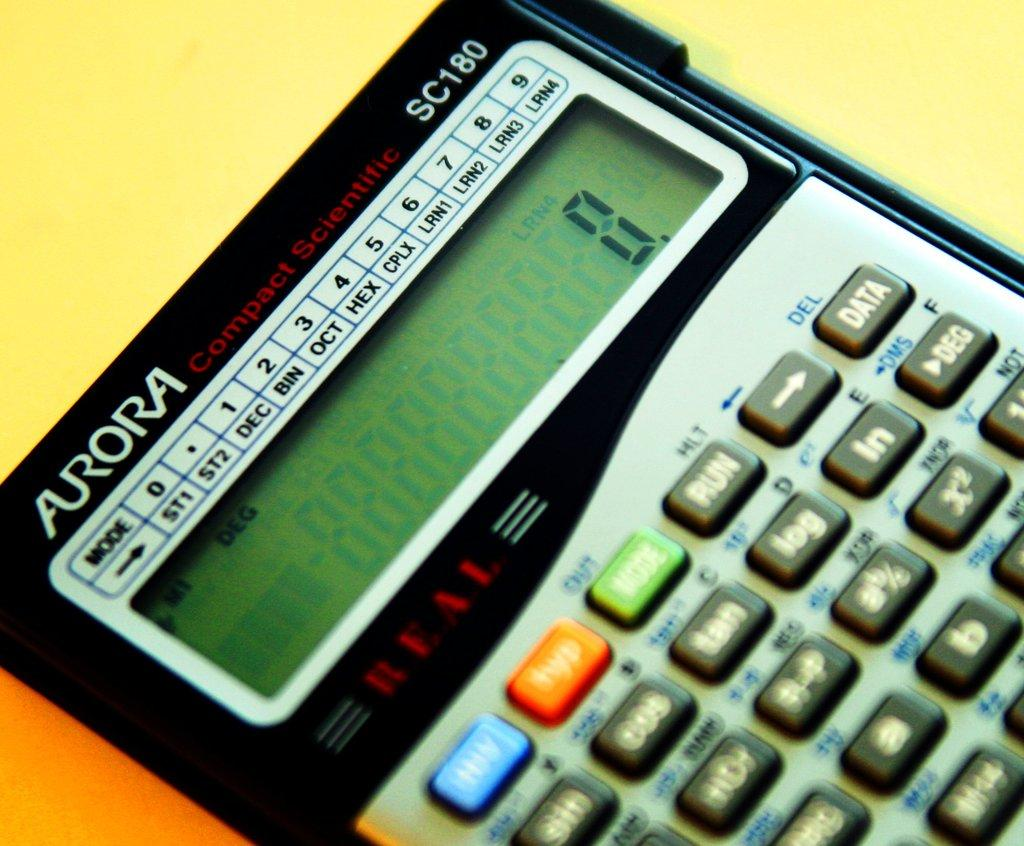<image>
Create a compact narrative representing the image presented. A black and white calculator made by Aurora has a 0 number on the face. 